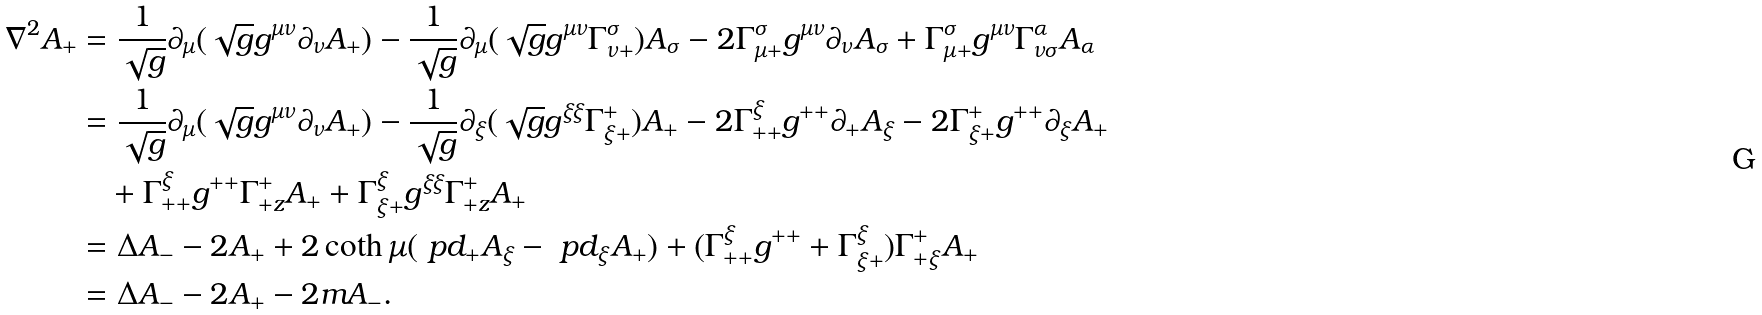Convert formula to latex. <formula><loc_0><loc_0><loc_500><loc_500>\nabla ^ { 2 } A _ { + } & = \frac { 1 } { \sqrt { g } } \partial _ { \mu } ( \sqrt { g } g ^ { \mu \nu } \partial _ { \nu } A _ { + } ) - \frac { 1 } { \sqrt { g } } \partial _ { \mu } ( \sqrt { g } g ^ { \mu \nu } \Gamma _ { \nu + } ^ { \sigma } ) A _ { \sigma } - 2 \Gamma ^ { \sigma } _ { \mu + } g ^ { \mu \nu } \partial _ { \nu } A _ { \sigma } + \Gamma ^ { \sigma } _ { \mu + } g ^ { \mu \nu } \Gamma _ { \nu \sigma } ^ { \alpha } A _ { \alpha } \\ & = \frac { 1 } { \sqrt { g } } \partial _ { \mu } ( \sqrt { g } g ^ { \mu \nu } \partial _ { \nu } A _ { + } ) - \frac { 1 } { \sqrt { g } } \partial _ { \xi } ( \sqrt { g } g ^ { \xi \xi } \Gamma _ { \xi + } ^ { + } ) A _ { + } - 2 \Gamma ^ { \xi } _ { + + } g ^ { + + } \partial _ { + } A _ { \xi } - 2 \Gamma ^ { + } _ { \xi + } g ^ { + + } \partial _ { \xi } A _ { + } \\ & \quad + \Gamma ^ { \xi } _ { + + } g ^ { + + } \Gamma _ { + z } ^ { + } A _ { + } + \Gamma ^ { \xi } _ { \xi + } g ^ { \xi \xi } \Gamma _ { + z } ^ { + } A _ { + } \\ & = \Delta A _ { - } - 2 A _ { + } + 2 \coth \mu ( \ p d _ { + } A _ { \xi } - \ p d _ { \xi } A _ { + } ) + ( \Gamma ^ { \xi } _ { + + } g ^ { + + } + \Gamma ^ { \xi } _ { \xi + } ) \Gamma _ { + \xi } ^ { + } A _ { + } \\ & = \Delta A _ { - } - 2 A _ { + } - 2 m A _ { - } .</formula> 